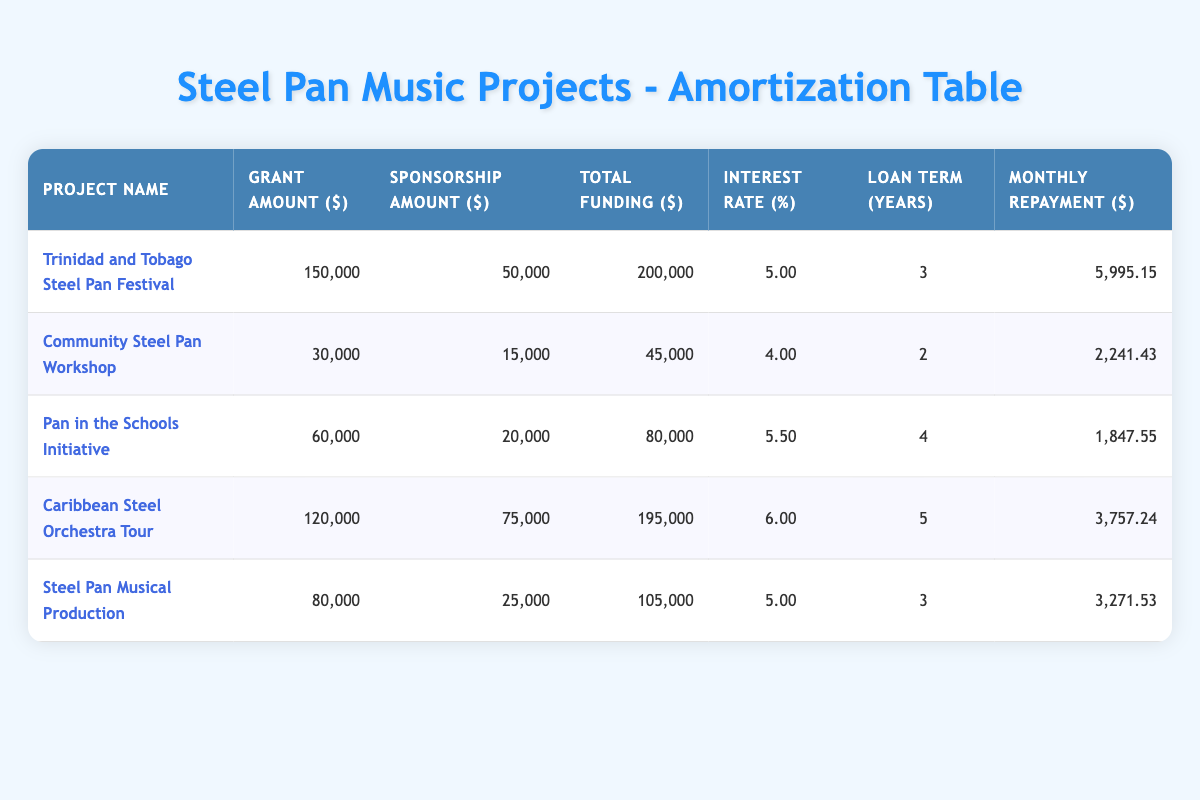What is the total funding amount for the Community Steel Pan Workshop? The table shows the total funding for the Community Steel Pan Workshop as 45,000. This value is directly listed in the corresponding row for this project.
Answer: 45,000 How much is the monthly repayment for the Trinidad and Tobago Steel Pan Festival? According to the table, the monthly repayment for this festival is listed as 5,995.15. This can be found in the section for that specific project in the table.
Answer: 5,995.15 Which project has the highest total funding? Examining the total funding column of the table, the project with the highest value is the Trinidad and Tobago Steel Pan Festival at 200,000. It appears at the top of the funding list.
Answer: Trinidad and Tobago Steel Pan Festival What is the average interest rate for all the projects? To find the average interest rate, we add all the interest rates: 5 + 4 + 5.5 + 6 + 5 = 25.5. Then, we divide by the number of projects (5) to get 25.5/5 = 5.1.
Answer: 5.1 Is the total grant amount for the Caribbean Steel Orchestra Tour greater than the total grant amount for the Steel Pan Musical Production? The table shows that the total grant amount for the Caribbean Steel Orchestra Tour is 120,000 and for the Steel Pan Musical Production it is 80,000. Since 120,000 is greater than 80,000, the answer is yes.
Answer: Yes What is the difference in monthly repayment between the Pan in the Schools Initiative and the Community Steel Pan Workshop? The monthly repayment for the Pan in the Schools Initiative is 1,847.55 and for the Community Steel Pan Workshop it is 2,241.43. The difference is calculated as 2,241.43 - 1,847.55 = 393.88.
Answer: 393.88 Which project has the smallest monthly repayment? Looking at the monthly repayment column, the smallest figure is for the Pan in the Schools Initiative, which has a monthly repayment of 1,847.55. This project appears to be the most economically manageable.
Answer: Pan in the Schools Initiative How much more funding does the Caribbean Steel Orchestra Tour receive compared to the Pan in the Schools Initiative? For the Caribbean Steel Orchestra Tour, the total funding is 195,000, while for the Pan in the Schools Initiative, it is 80,000. The difference in funding is calculated as 195,000 - 80,000 = 115,000.
Answer: 115,000 Does the Community Steel Pan Workshop have a higher interest rate than the Steel Pan Musical Production? The interest rate for the Community Steel Pan Workshop is 4.00, while for the Steel Pan Musical Production it is 5.00. Since 4.00 is less than 5.00, the answer is no.
Answer: No 